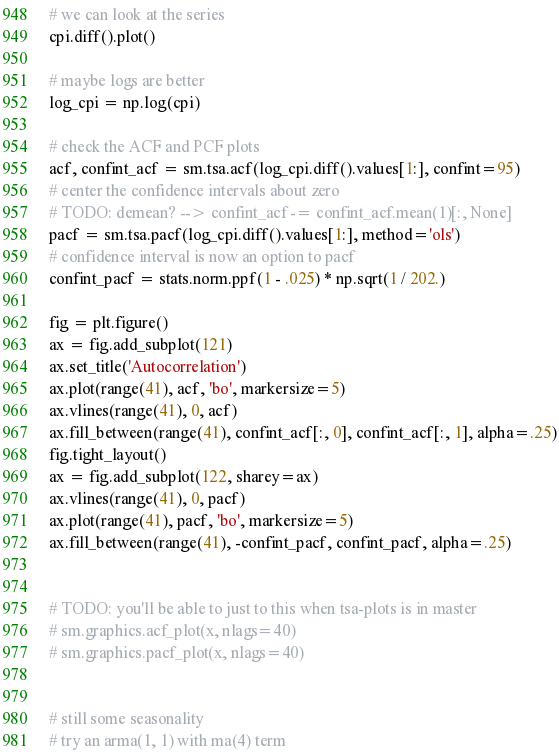Convert code to text. <code><loc_0><loc_0><loc_500><loc_500><_Python_>
# we can look at the series
cpi.diff().plot()

# maybe logs are better
log_cpi = np.log(cpi)

# check the ACF and PCF plots
acf, confint_acf = sm.tsa.acf(log_cpi.diff().values[1:], confint=95)
# center the confidence intervals about zero
# TODO: demean? --> confint_acf -= confint_acf.mean(1)[:, None]
pacf = sm.tsa.pacf(log_cpi.diff().values[1:], method='ols')
# confidence interval is now an option to pacf
confint_pacf = stats.norm.ppf(1 - .025) * np.sqrt(1 / 202.)

fig = plt.figure()
ax = fig.add_subplot(121)
ax.set_title('Autocorrelation')
ax.plot(range(41), acf, 'bo', markersize=5)
ax.vlines(range(41), 0, acf)
ax.fill_between(range(41), confint_acf[:, 0], confint_acf[:, 1], alpha=.25)
fig.tight_layout()
ax = fig.add_subplot(122, sharey=ax)
ax.vlines(range(41), 0, pacf)
ax.plot(range(41), pacf, 'bo', markersize=5)
ax.fill_between(range(41), -confint_pacf, confint_pacf, alpha=.25)


# TODO: you'll be able to just to this when tsa-plots is in master
# sm.graphics.acf_plot(x, nlags=40)
# sm.graphics.pacf_plot(x, nlags=40)


# still some seasonality
# try an arma(1, 1) with ma(4) term
</code> 